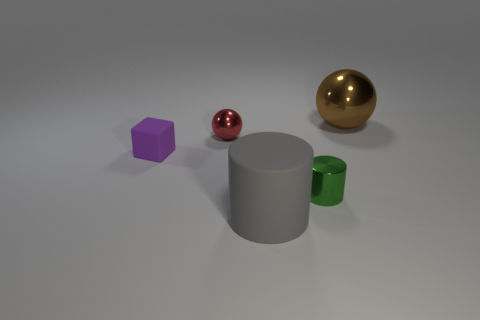Add 4 gray matte cylinders. How many objects exist? 9 Subtract all green cylinders. How many cylinders are left? 1 Subtract all blocks. How many objects are left? 4 Subtract 1 spheres. How many spheres are left? 1 Add 2 green things. How many green things are left? 3 Add 4 small gray shiny cylinders. How many small gray shiny cylinders exist? 4 Subtract 0 red cubes. How many objects are left? 5 Subtract all gray cylinders. Subtract all cyan blocks. How many cylinders are left? 1 Subtract all gray cylinders. How many purple balls are left? 0 Subtract all purple rubber things. Subtract all green objects. How many objects are left? 3 